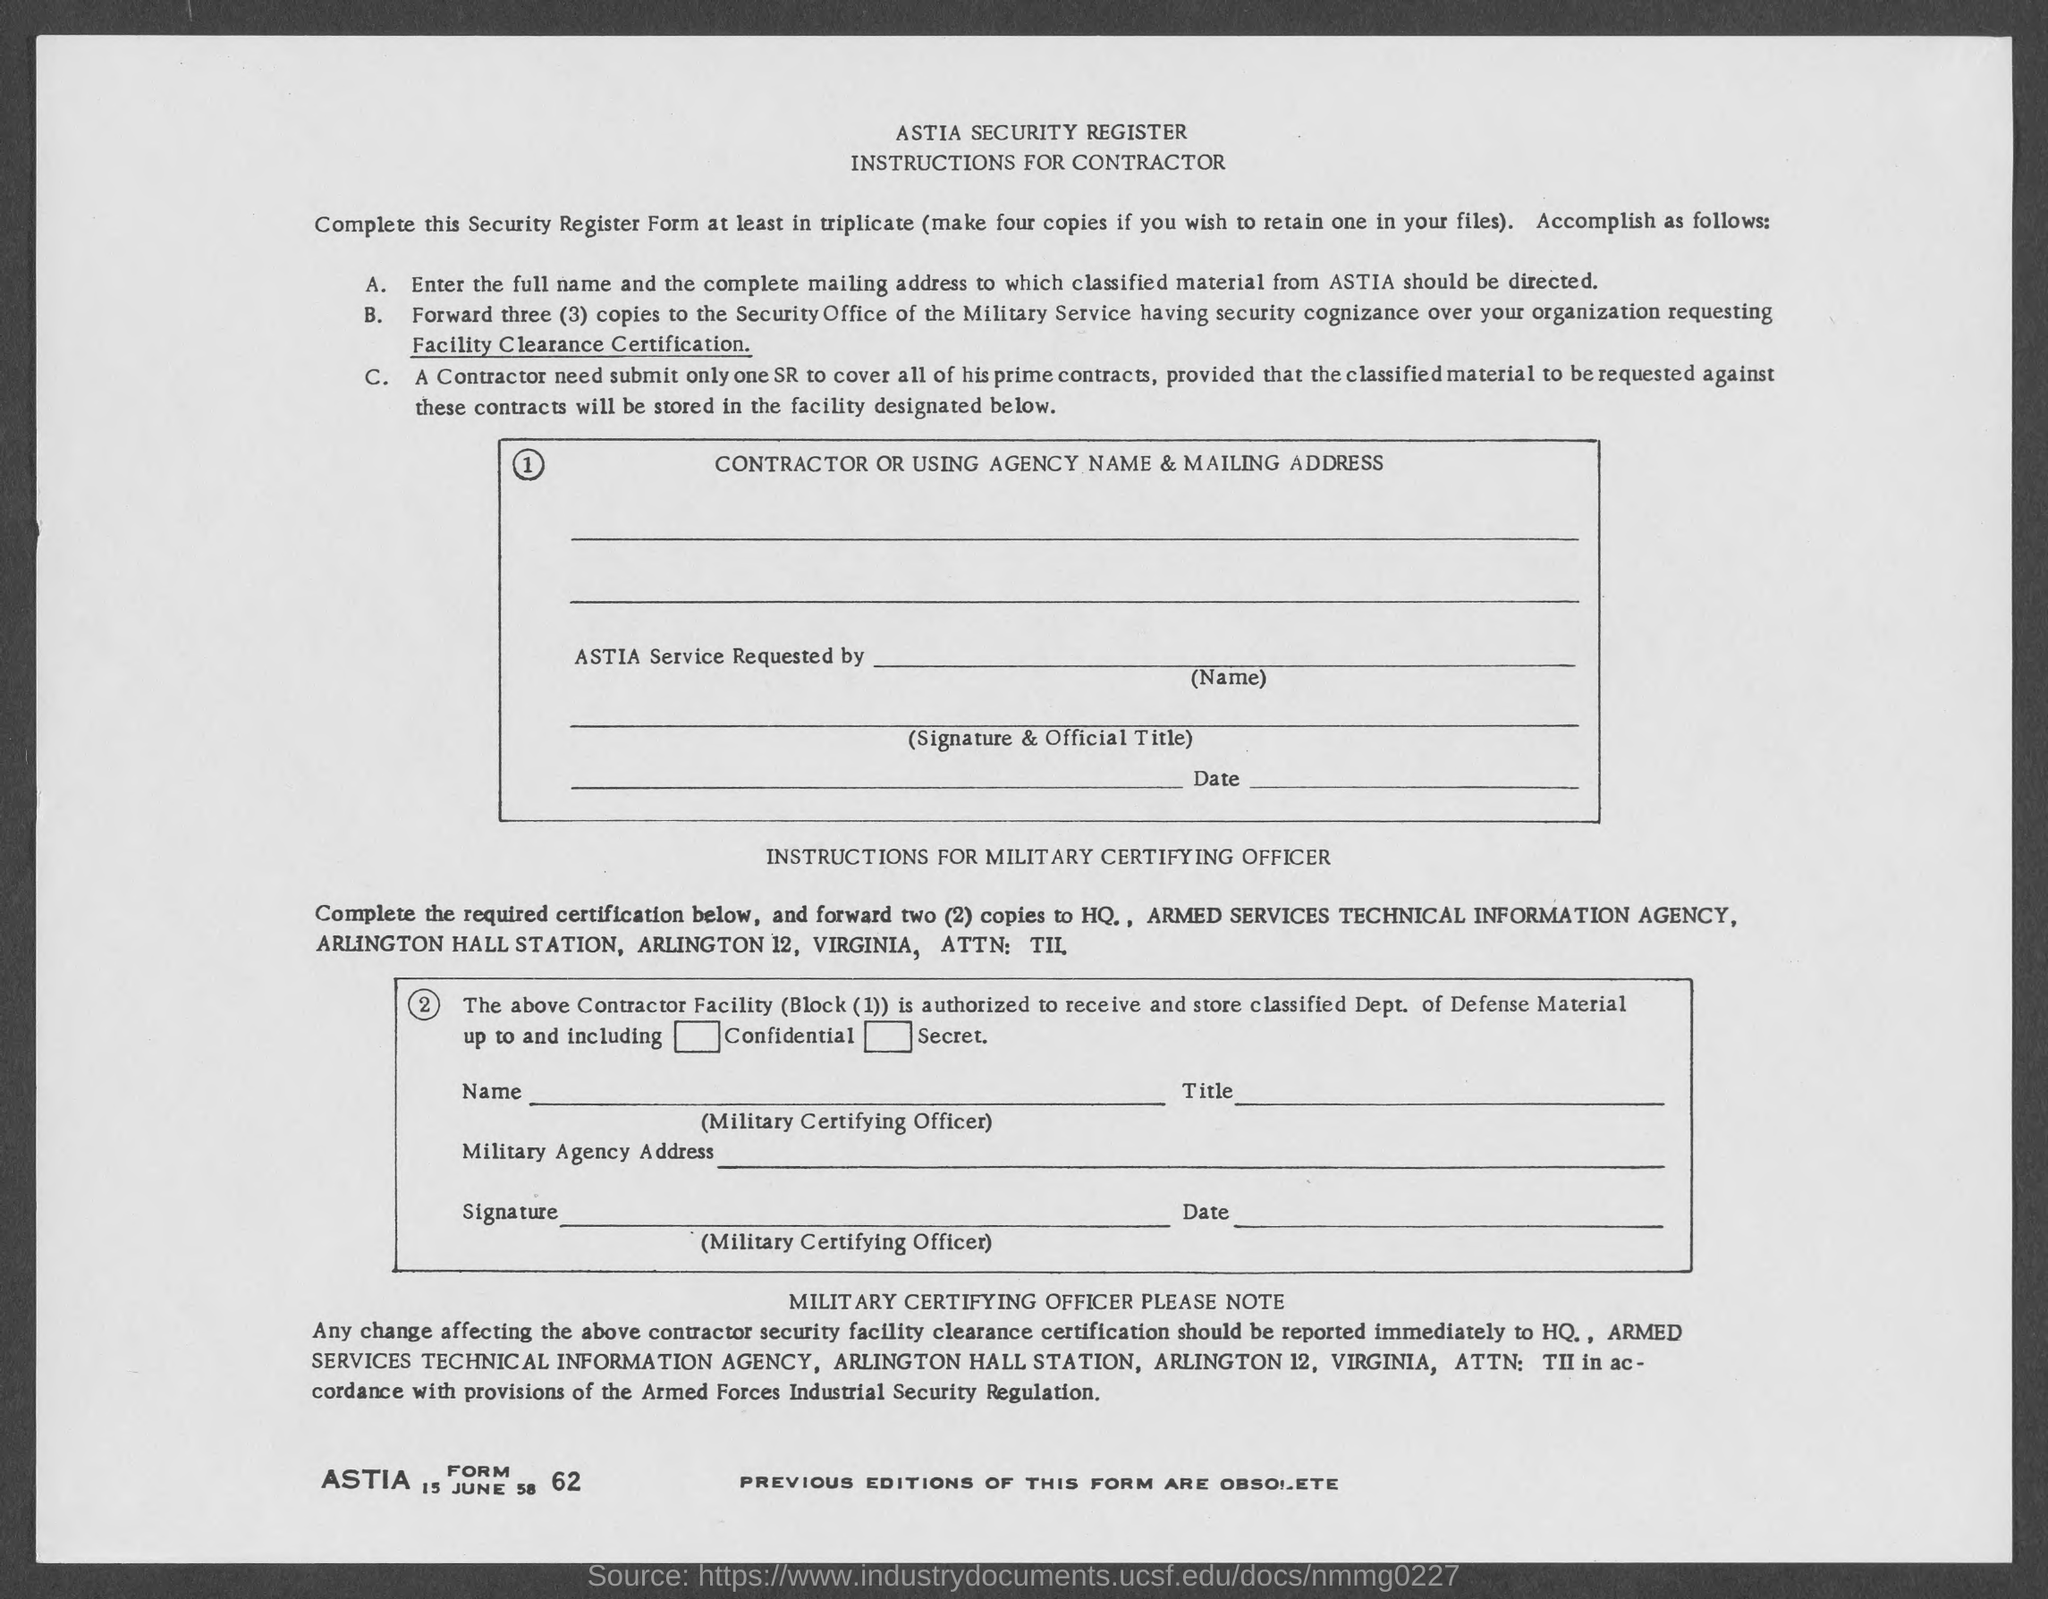Indicate a few pertinent items in this graphic. The date mentioned in the form is 15 June 58. The ASTIA form number is 62. The full form of ASTIA is the Armed Services Technical Information Agency. 